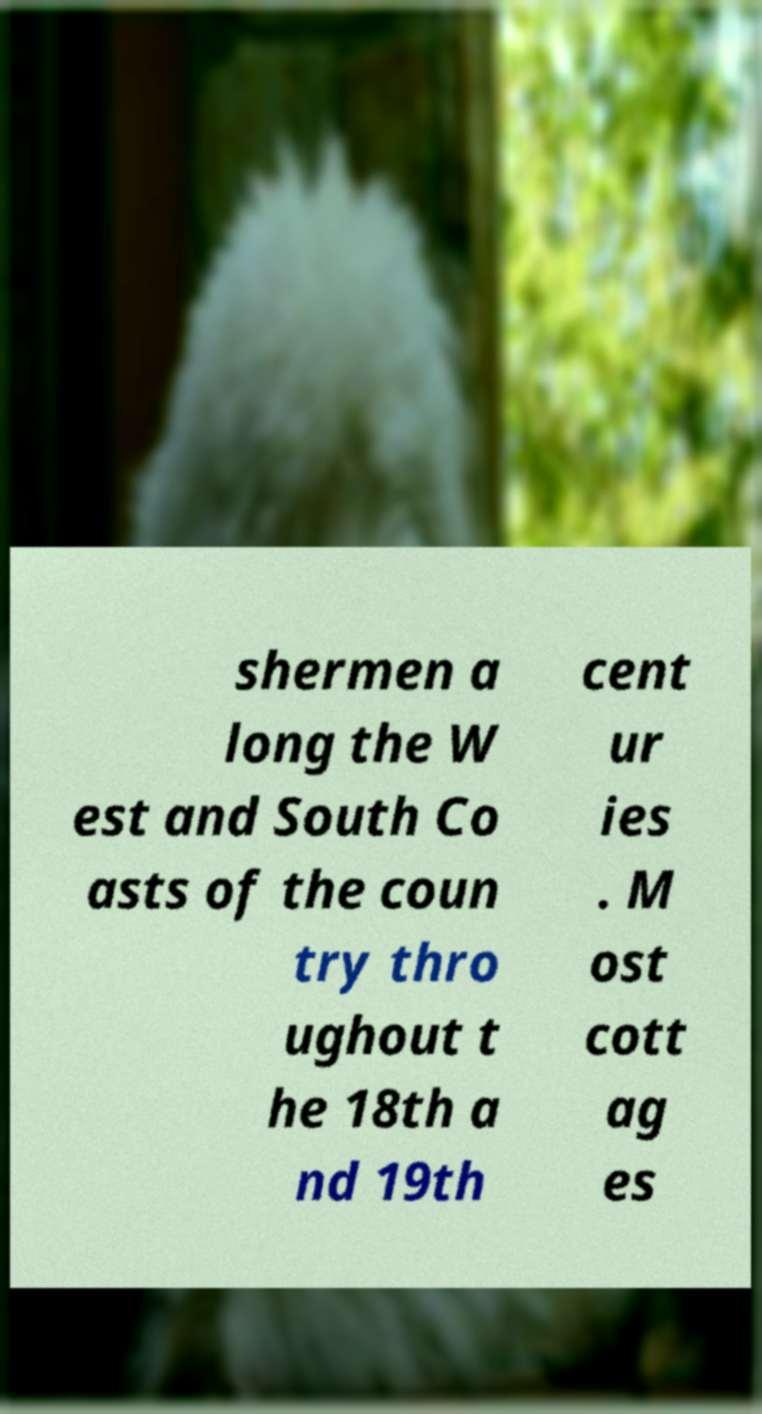There's text embedded in this image that I need extracted. Can you transcribe it verbatim? shermen a long the W est and South Co asts of the coun try thro ughout t he 18th a nd 19th cent ur ies . M ost cott ag es 